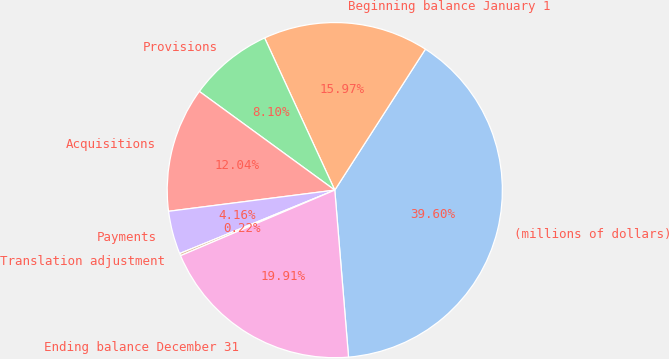Convert chart. <chart><loc_0><loc_0><loc_500><loc_500><pie_chart><fcel>(millions of dollars)<fcel>Beginning balance January 1<fcel>Provisions<fcel>Acquisitions<fcel>Payments<fcel>Translation adjustment<fcel>Ending balance December 31<nl><fcel>39.6%<fcel>15.97%<fcel>8.1%<fcel>12.04%<fcel>4.16%<fcel>0.22%<fcel>19.91%<nl></chart> 